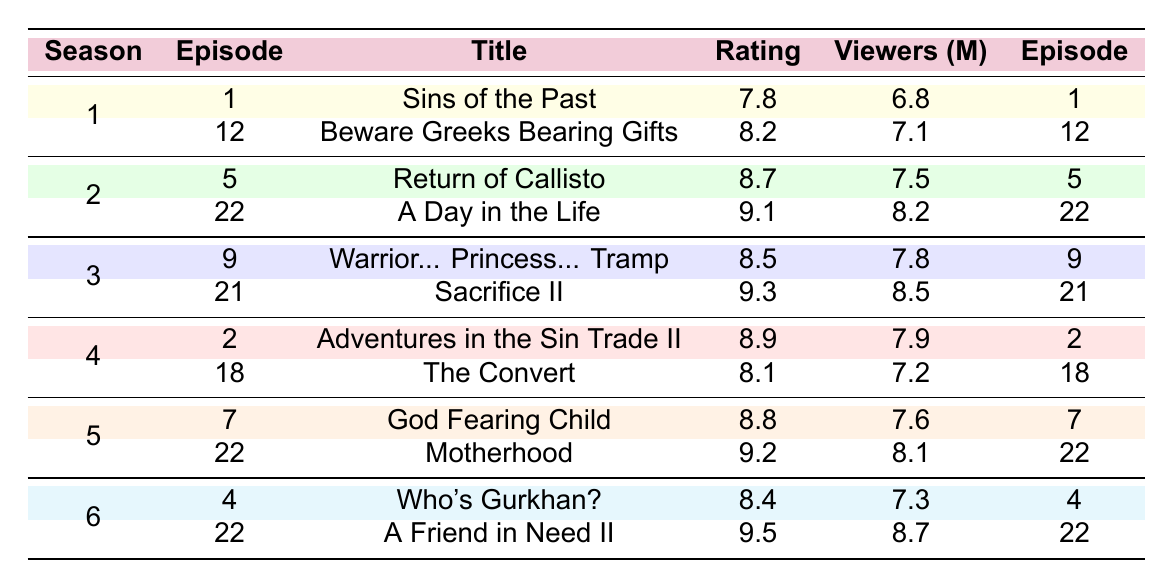What is the highest-rated episode in the series? According to the table, the episode with the highest rating is "A Friend in Need II" from season 6 with a rating of 9.5.
Answer: 9.5 Which season had the most episodes listed in the table? The table shows that each season has 2 episodes listed, thus no season has more episodes than another.
Answer: No season has more episodes What was the viewership of the episode "Motherhood"? By checking the table, "Motherhood" from season 5 is listed with 8.1 million viewers.
Answer: 8.1 million Which episode from season 4 had the lowest rating? In season 4, the episode "The Convert" has the lowest rating of 8.1, compared to "Adventures in the Sin Trade II" which is rated higher at 8.9.
Answer: The Convert What is the average rating across all episodes in season 2? To find the average rating for season 2, add the ratings (8.7 + 9.1) = 17.8 and then divide by the number of episodes (2), resulting in 17.8 / 2 = 8.9.
Answer: 8.9 Did any episode have more viewers than "Sacrifice II"? "Sacrifice II" had 8.5 million viewers. By checking the table, it’s confirmed that no other episodes have more viewers; "A Friend in Need II" has 8.7 million, which is more.
Answer: Yes, A Friend in Need II had more viewers Which episode from season 5 had the highest rating? Looking at the entries for season 5, "Motherhood" has a higher rating of 9.2 compared to "God Fearing Child" which has a rating of 8.8.
Answer: Motherhood What is the total viewers across all episodes from season 1? Summing the viewers for season 1, "Sins of the Past" has 6.8 million and "Beware Greeks Bearing Gifts" has 7.1 million. Thus, the total is 6.8 + 7.1 = 13.9 million.
Answer: 13.9 million Which season had the episode with the title "Return of Callisto"? The table shows "Return of Callisto" is from season 2.
Answer: Season 2 What is the difference in viewers between the highest and lowest rated episodes? The highest-rated episode "A Friend in Need II" had 8.7 million viewers and the lowest-rated episode "The Convert" had 7.2 million viewers. The difference is 8.7 - 7.2 = 1.5 million.
Answer: 1.5 million Which season has the episode with the title "Warrior... Princess... Tramp"? From the table, "Warrior... Princess... Tramp" is listed as part of season 3.
Answer: Season 3 